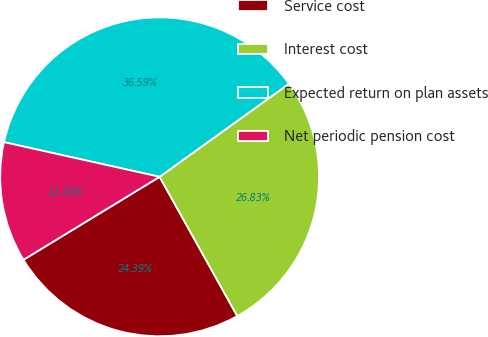<chart> <loc_0><loc_0><loc_500><loc_500><pie_chart><fcel>Service cost<fcel>Interest cost<fcel>Expected return on plan assets<fcel>Net periodic pension cost<nl><fcel>24.39%<fcel>26.83%<fcel>36.59%<fcel>12.2%<nl></chart> 